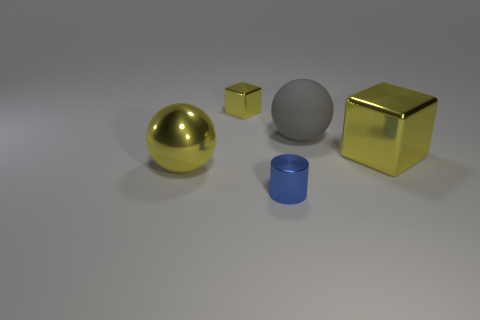What number of other objects are there of the same shape as the tiny blue shiny object?
Offer a terse response. 0. There is a ball that is the same color as the tiny shiny cube; what size is it?
Make the answer very short. Large. What number of green matte spheres are the same size as the metal cylinder?
Make the answer very short. 0. Is the number of small yellow metallic objects behind the tiny metallic cylinder the same as the number of big things?
Your answer should be very brief. No. What number of tiny shiny things are in front of the metallic sphere and behind the gray rubber sphere?
Provide a succinct answer. 0. The cylinder that is made of the same material as the small block is what size?
Give a very brief answer. Small. How many other small metal things have the same shape as the tiny yellow thing?
Your response must be concise. 0. Are there more big gray spheres that are behind the gray ball than tiny yellow things?
Ensure brevity in your answer.  No. The object that is both behind the large yellow shiny cube and left of the gray ball has what shape?
Make the answer very short. Cube. Do the blue metallic cylinder and the matte sphere have the same size?
Your answer should be compact. No. 